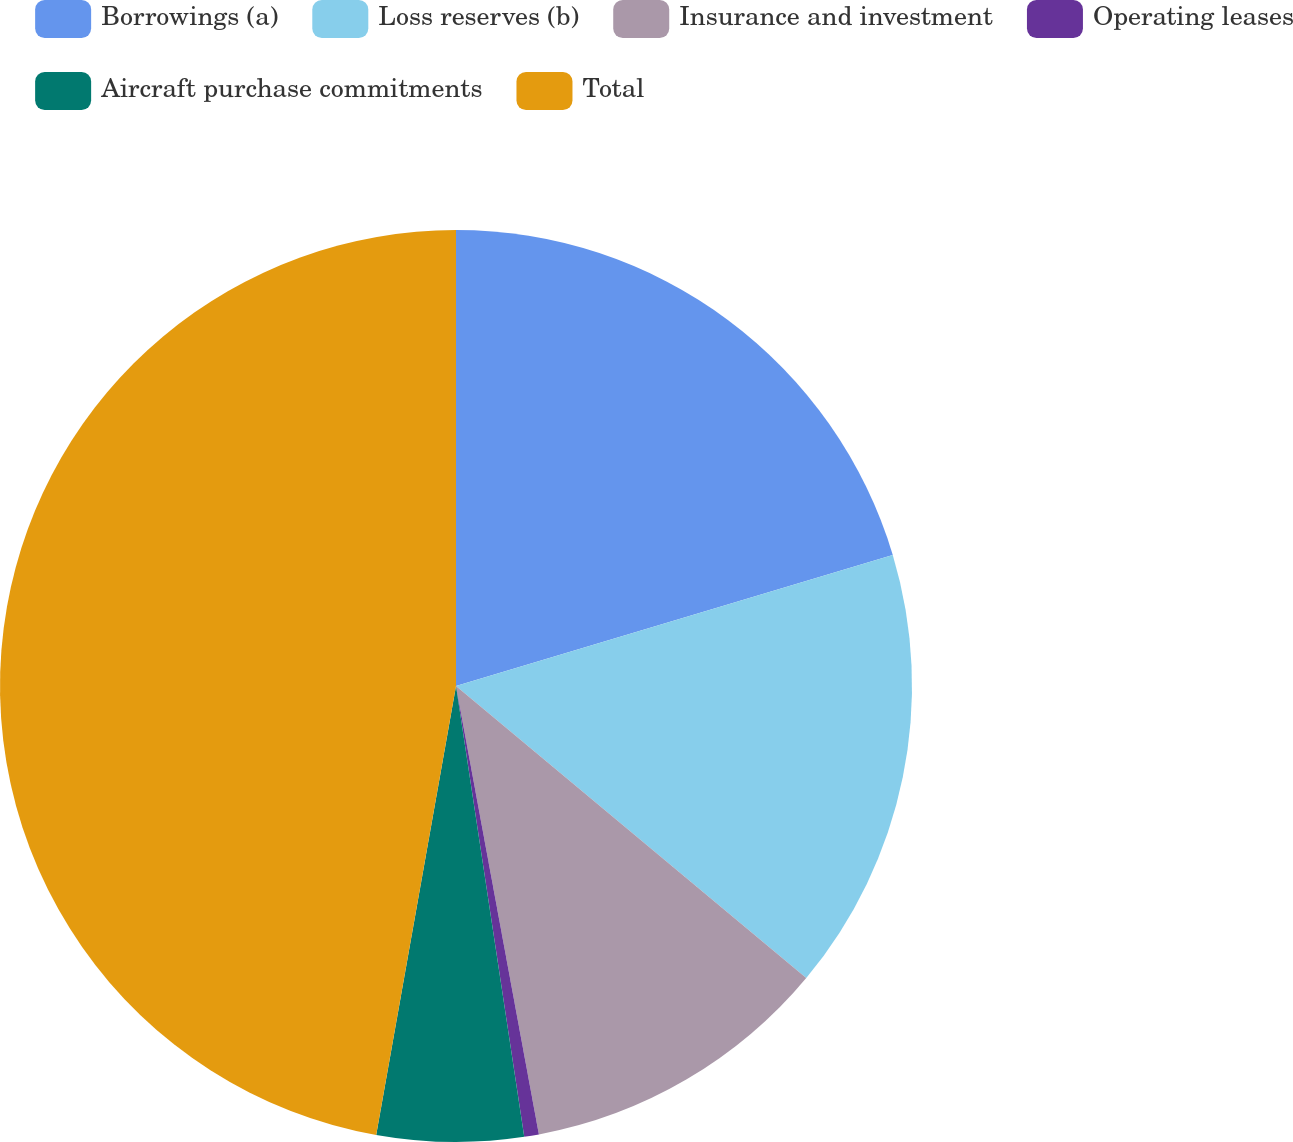<chart> <loc_0><loc_0><loc_500><loc_500><pie_chart><fcel>Borrowings (a)<fcel>Loss reserves (b)<fcel>Insurance and investment<fcel>Operating leases<fcel>Aircraft purchase commitments<fcel>Total<nl><fcel>20.36%<fcel>15.7%<fcel>11.03%<fcel>0.52%<fcel>5.19%<fcel>47.2%<nl></chart> 